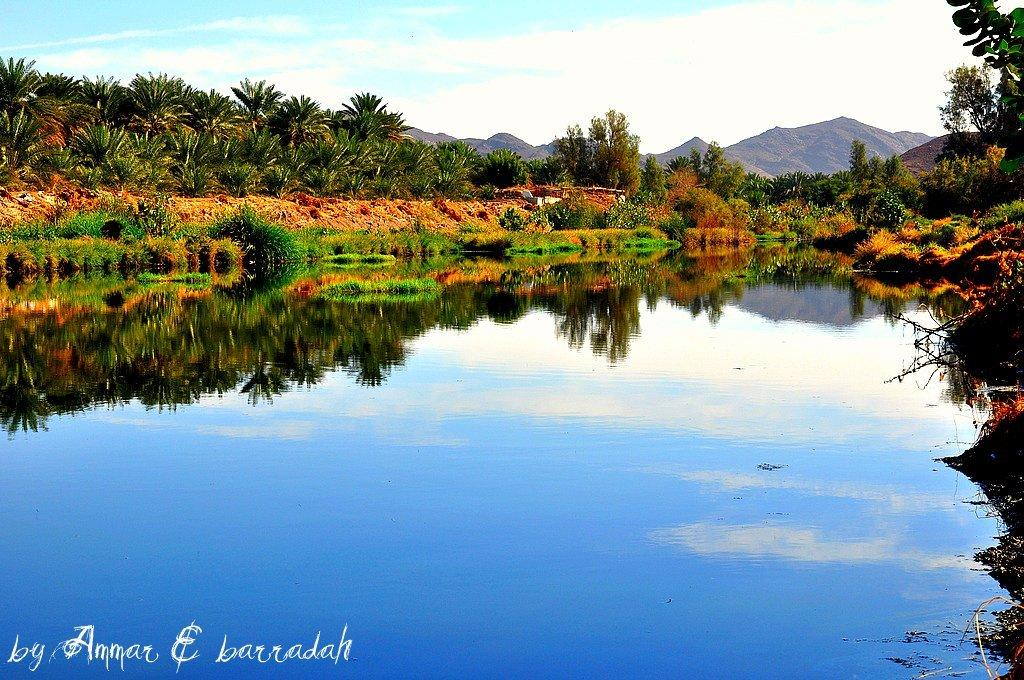What type of vegetation is present in the image? There are many trees, plants, and grass in the image. What natural features can be seen in the image? There is water visible in the image, as well as mountains in the background. What part of the sky is visible in the image? The sky is visible in the background of the image. Is there any text or marking on the image? Yes, there is a watermark at the bottom of the image. Can you describe the woman walking through the trees in the image? There is no woman present in the image; it features only natural elements such as trees, plants, grass, water, mountains, and the sky. 